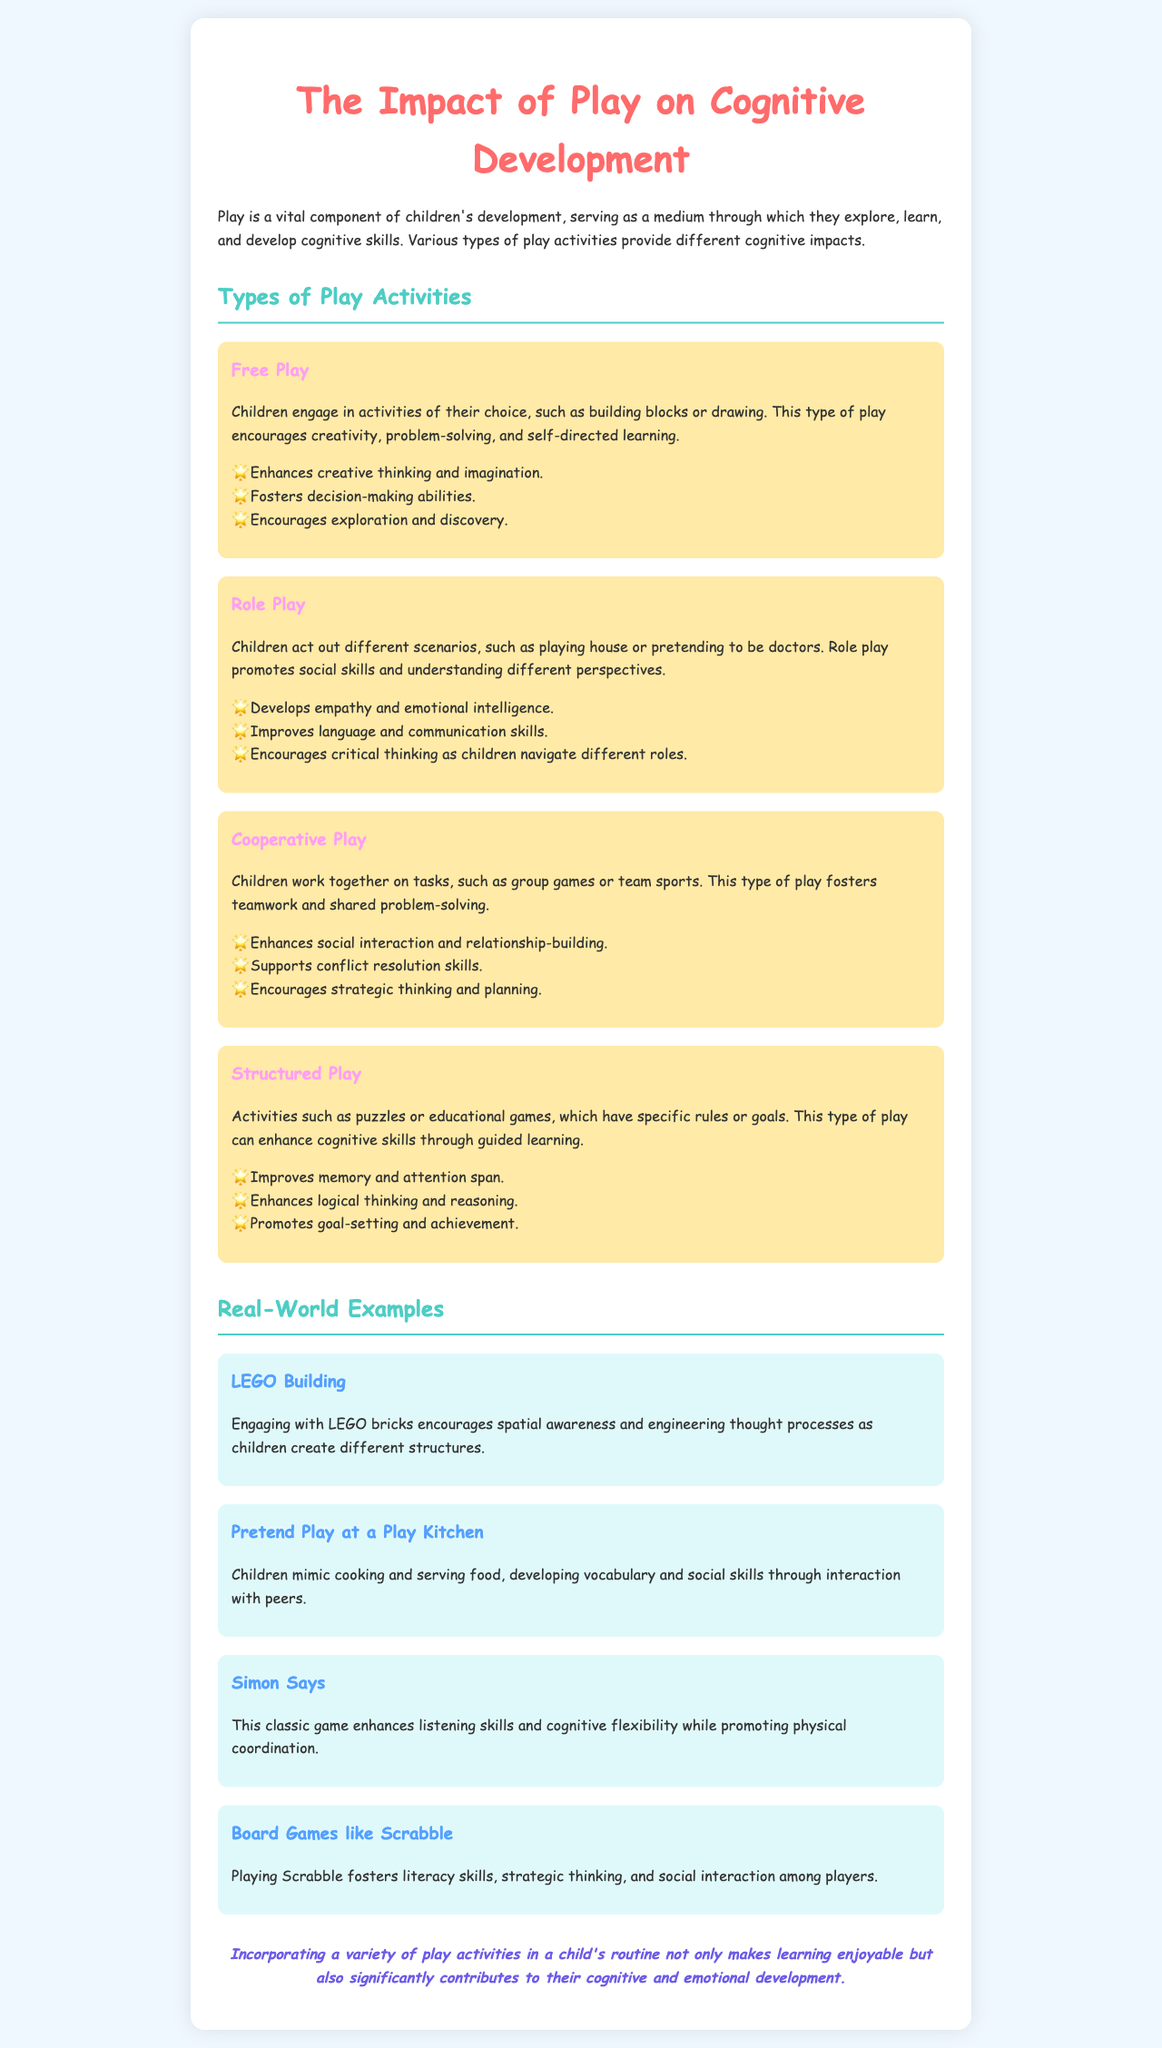What are the four types of play activities mentioned? The document lists four types of play activities: Free Play, Role Play, Cooperative Play, and Structured Play.
Answer: Free Play, Role Play, Cooperative Play, Structured Play What does Free Play enhance? Free Play enhances creative thinking and imagination as mentioned in the document.
Answer: Creative thinking and imagination What skill does Role Play develop? Role Play develops empathy and emotional intelligence as highlighted in the description.
Answer: Empathy and emotional intelligence Which example involves listening skills? The game "Simon Says" is specifically mentioned as enhancing listening skills in the real-world examples.
Answer: Simon Says What is improved by Structured Play? Structured Play improves memory and attention span according to the documented activities.
Answer: Memory and attention span How does Cooperative Play support development? Cooperative Play supports conflict resolution skills as detailed in the activity section.
Answer: Conflict resolution skills What cognitive skill is fostered by playing Scrabble? The document states that playing Scrabble fosters literacy skills.
Answer: Literacy skills Which type of play promotes teamwork? The document indicates that Cooperative Play promotes teamwork among children.
Answer: Cooperative Play What cognitive benefit is derived from LEGO building? Engaging with LEGO building enhances spatial awareness, according to the examples provided.
Answer: Spatial awareness 